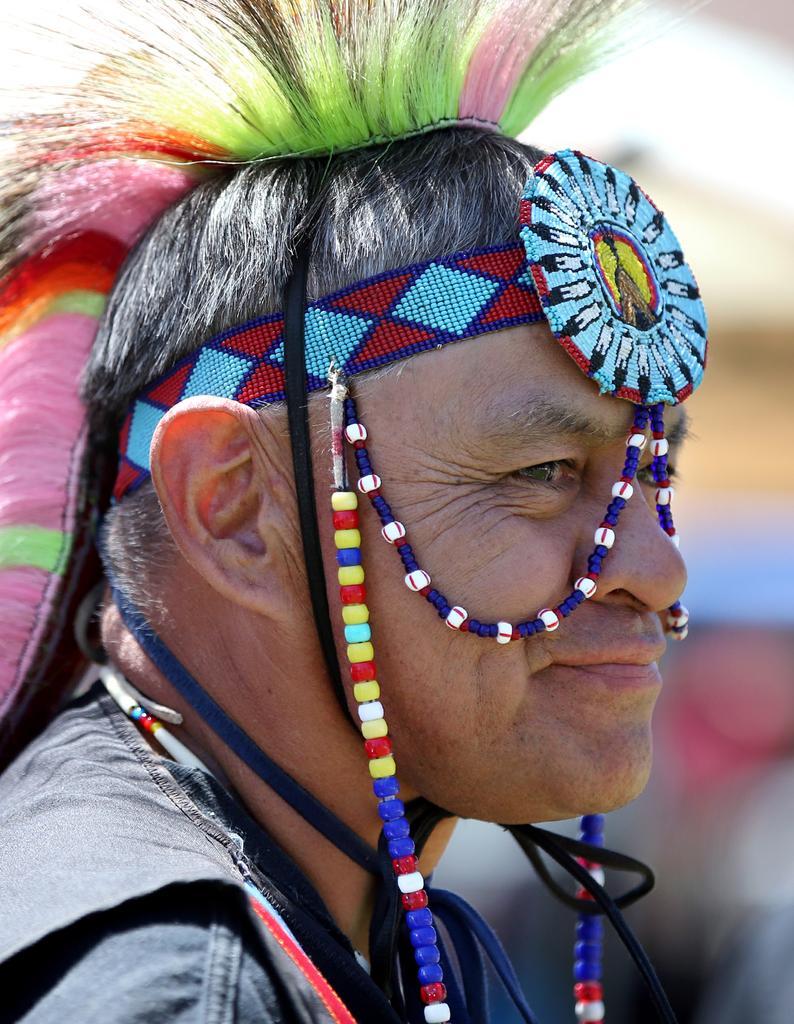Can you describe this image briefly? In this image there is a man wearing costumes, in the background it is blurred. 